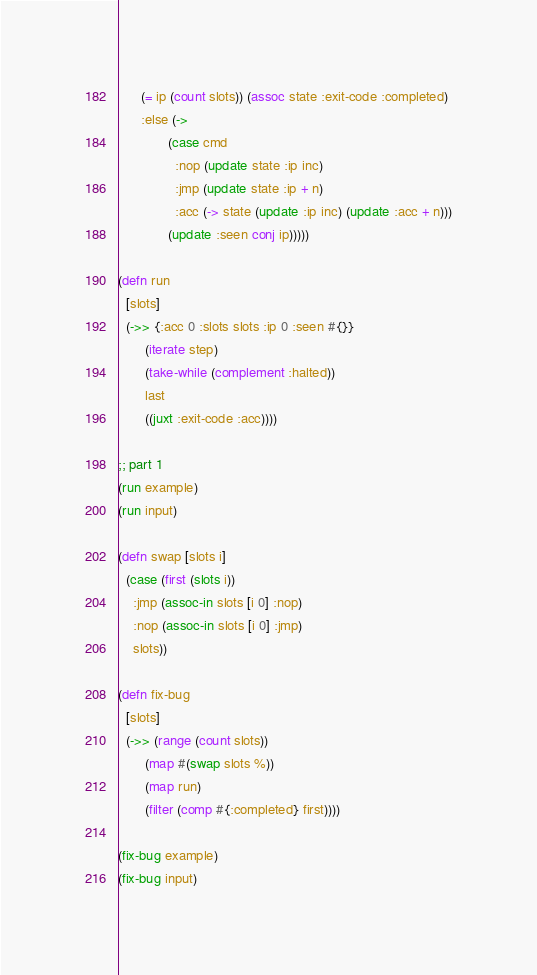Convert code to text. <code><loc_0><loc_0><loc_500><loc_500><_Clojure_>      (= ip (count slots)) (assoc state :exit-code :completed)
      :else (->
             (case cmd
               :nop (update state :ip inc)
               :jmp (update state :ip + n)
               :acc (-> state (update :ip inc) (update :acc + n)))
             (update :seen conj ip)))))

(defn run
  [slots]
  (->> {:acc 0 :slots slots :ip 0 :seen #{}}
       (iterate step)
       (take-while (complement :halted))
       last
       ((juxt :exit-code :acc))))

;; part 1
(run example)
(run input)

(defn swap [slots i]
  (case (first (slots i))
    :jmp (assoc-in slots [i 0] :nop)
    :nop (assoc-in slots [i 0] :jmp)
    slots))

(defn fix-bug
  [slots]
  (->> (range (count slots))
       (map #(swap slots %))
       (map run)
       (filter (comp #{:completed} first))))

(fix-bug example)
(fix-bug input)
</code> 